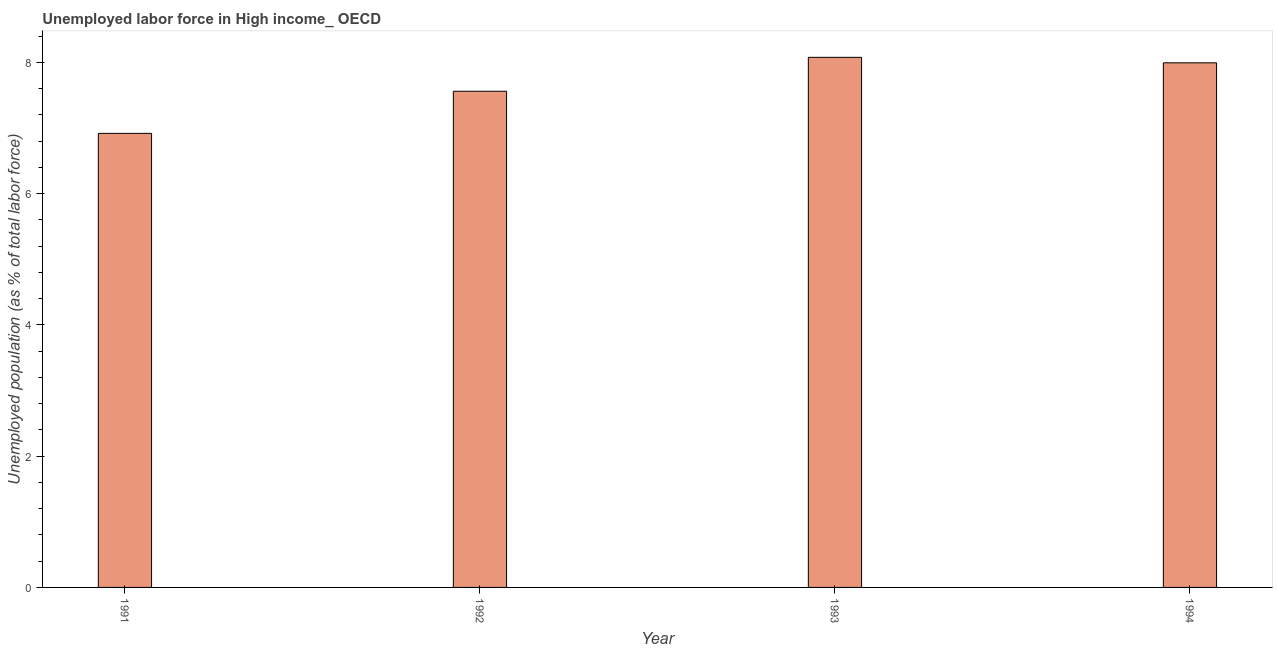Does the graph contain any zero values?
Provide a short and direct response. No. What is the title of the graph?
Make the answer very short. Unemployed labor force in High income_ OECD. What is the label or title of the Y-axis?
Give a very brief answer. Unemployed population (as % of total labor force). What is the total unemployed population in 1993?
Your answer should be compact. 8.08. Across all years, what is the maximum total unemployed population?
Offer a terse response. 8.08. Across all years, what is the minimum total unemployed population?
Your answer should be very brief. 6.92. What is the sum of the total unemployed population?
Make the answer very short. 30.55. What is the difference between the total unemployed population in 1991 and 1994?
Offer a terse response. -1.07. What is the average total unemployed population per year?
Offer a very short reply. 7.64. What is the median total unemployed population?
Your response must be concise. 7.78. In how many years, is the total unemployed population greater than 3.2 %?
Your answer should be compact. 4. Do a majority of the years between 1991 and 1994 (inclusive) have total unemployed population greater than 5.2 %?
Provide a succinct answer. Yes. What is the ratio of the total unemployed population in 1993 to that in 1994?
Your answer should be compact. 1.01. Is the total unemployed population in 1991 less than that in 1993?
Your answer should be compact. Yes. What is the difference between the highest and the second highest total unemployed population?
Your answer should be very brief. 0.08. Is the sum of the total unemployed population in 1993 and 1994 greater than the maximum total unemployed population across all years?
Make the answer very short. Yes. What is the difference between the highest and the lowest total unemployed population?
Your response must be concise. 1.16. Are all the bars in the graph horizontal?
Offer a very short reply. No. Are the values on the major ticks of Y-axis written in scientific E-notation?
Provide a short and direct response. No. What is the Unemployed population (as % of total labor force) of 1991?
Offer a very short reply. 6.92. What is the Unemployed population (as % of total labor force) in 1992?
Keep it short and to the point. 7.56. What is the Unemployed population (as % of total labor force) of 1993?
Make the answer very short. 8.08. What is the Unemployed population (as % of total labor force) of 1994?
Provide a short and direct response. 7.99. What is the difference between the Unemployed population (as % of total labor force) in 1991 and 1992?
Your answer should be very brief. -0.64. What is the difference between the Unemployed population (as % of total labor force) in 1991 and 1993?
Provide a succinct answer. -1.16. What is the difference between the Unemployed population (as % of total labor force) in 1991 and 1994?
Your response must be concise. -1.08. What is the difference between the Unemployed population (as % of total labor force) in 1992 and 1993?
Your answer should be very brief. -0.52. What is the difference between the Unemployed population (as % of total labor force) in 1992 and 1994?
Your response must be concise. -0.43. What is the difference between the Unemployed population (as % of total labor force) in 1993 and 1994?
Offer a very short reply. 0.08. What is the ratio of the Unemployed population (as % of total labor force) in 1991 to that in 1992?
Provide a short and direct response. 0.92. What is the ratio of the Unemployed population (as % of total labor force) in 1991 to that in 1993?
Your answer should be compact. 0.86. What is the ratio of the Unemployed population (as % of total labor force) in 1991 to that in 1994?
Your answer should be compact. 0.86. What is the ratio of the Unemployed population (as % of total labor force) in 1992 to that in 1993?
Your response must be concise. 0.94. What is the ratio of the Unemployed population (as % of total labor force) in 1992 to that in 1994?
Provide a succinct answer. 0.95. 